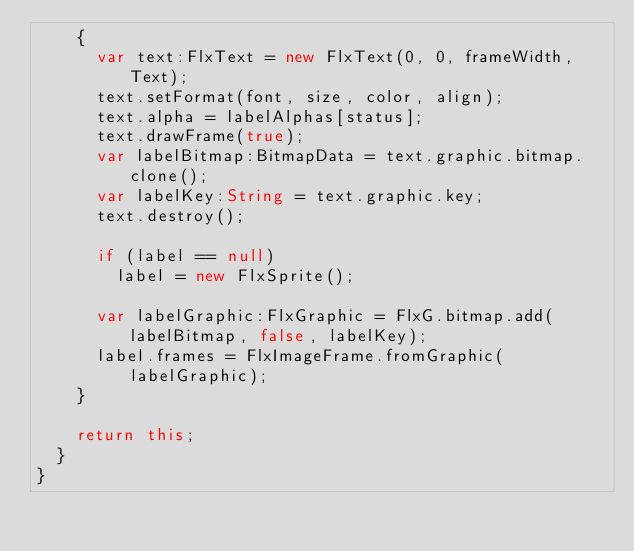<code> <loc_0><loc_0><loc_500><loc_500><_Haxe_>		{
			var text:FlxText = new FlxText(0, 0, frameWidth, Text);
			text.setFormat(font, size, color, align);
			text.alpha = labelAlphas[status];
			text.drawFrame(true);
			var labelBitmap:BitmapData = text.graphic.bitmap.clone();
			var labelKey:String = text.graphic.key;
			text.destroy();
			
			if (label == null)
				label = new FlxSprite();
			
			var labelGraphic:FlxGraphic = FlxG.bitmap.add(labelBitmap, false, labelKey);
			label.frames = FlxImageFrame.fromGraphic(labelGraphic);
		}
		
		return this;
	}
}</code> 